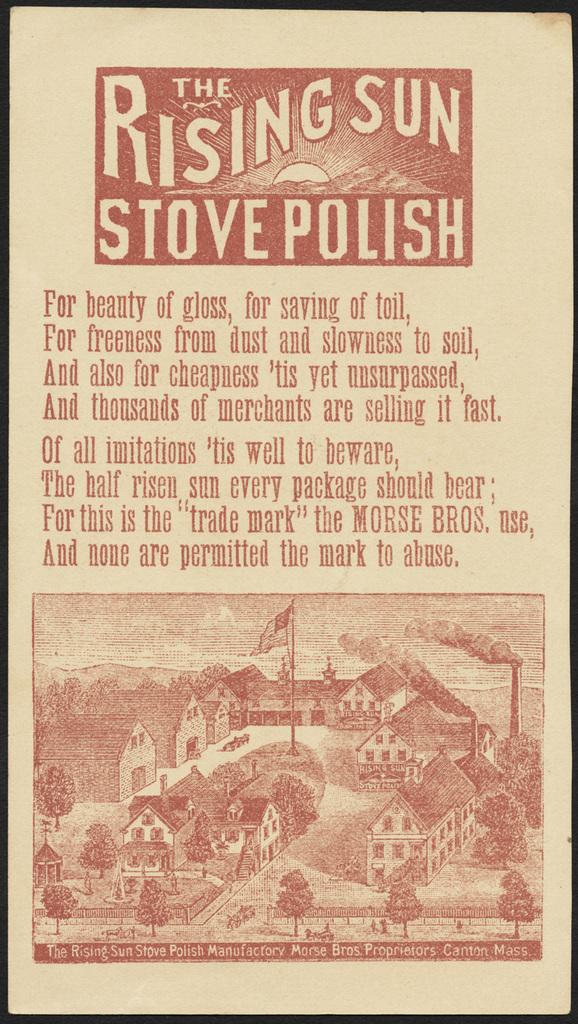<image>
Provide a brief description of the given image. An ad for the rising sun stove polish by Morse Bros. 